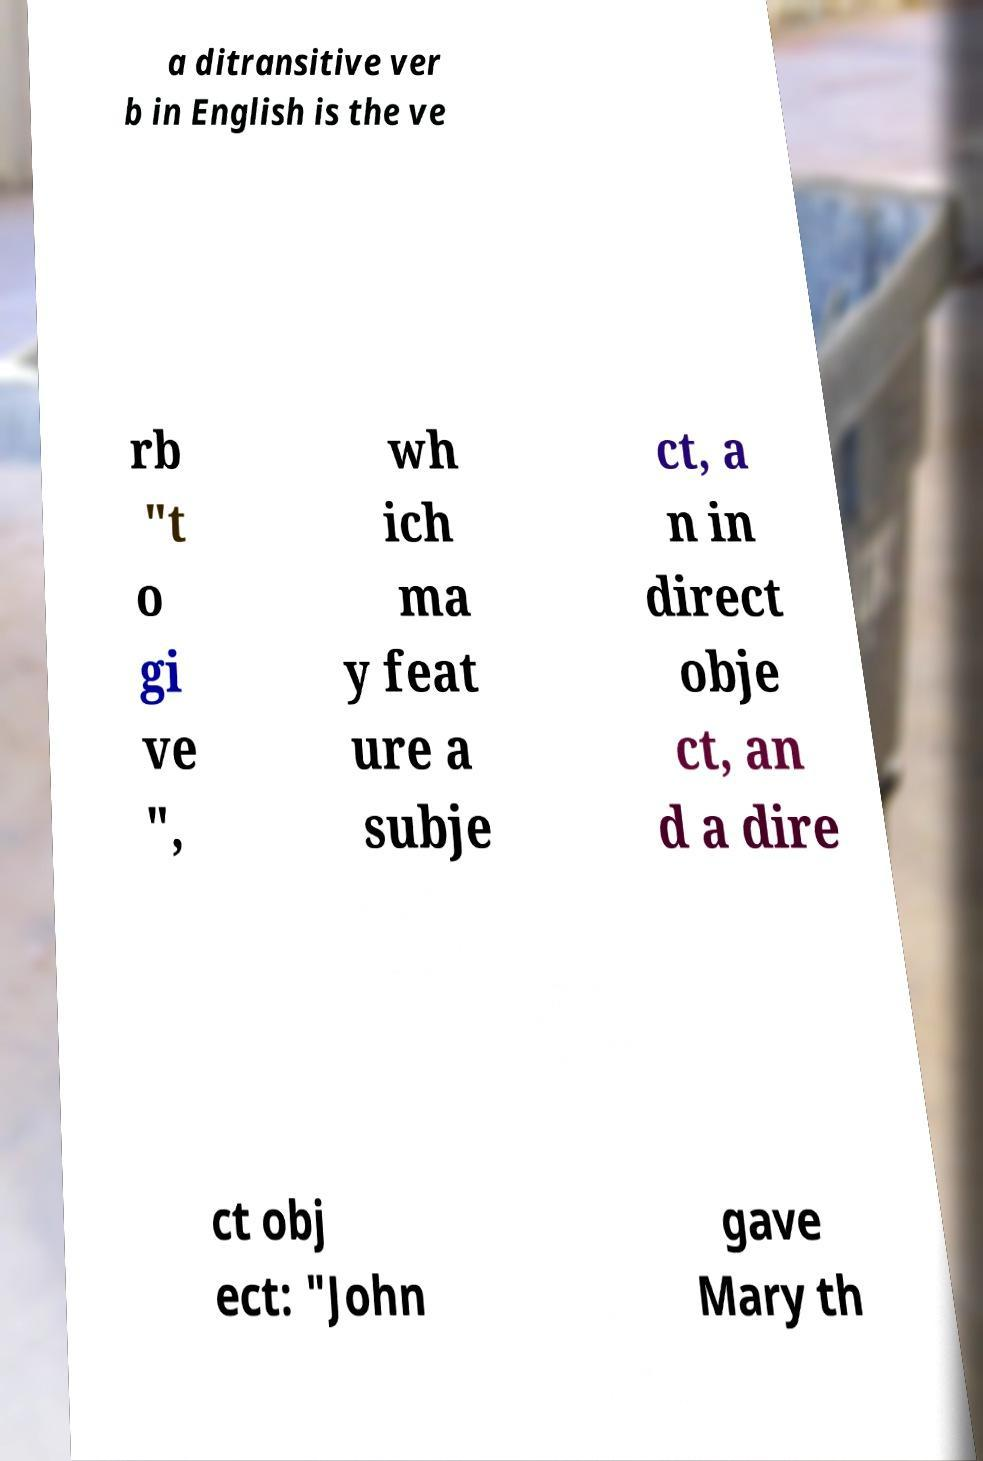There's text embedded in this image that I need extracted. Can you transcribe it verbatim? a ditransitive ver b in English is the ve rb "t o gi ve ", wh ich ma y feat ure a subje ct, a n in direct obje ct, an d a dire ct obj ect: "John gave Mary th 